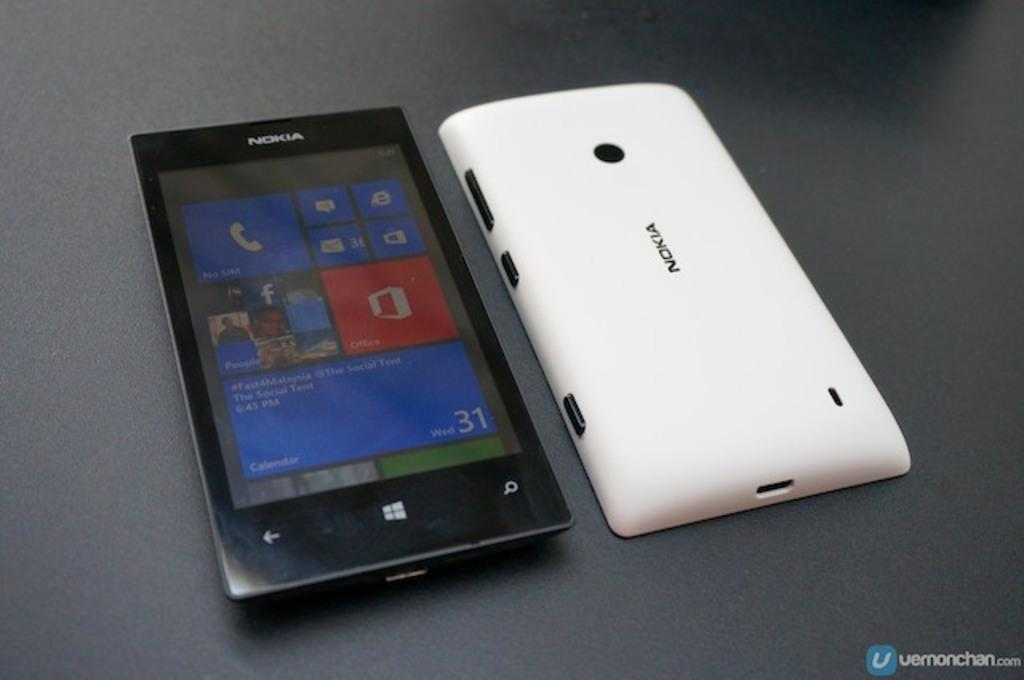Provide a one-sentence caption for the provided image. The front and back of a nokia cell phone is displayed. 